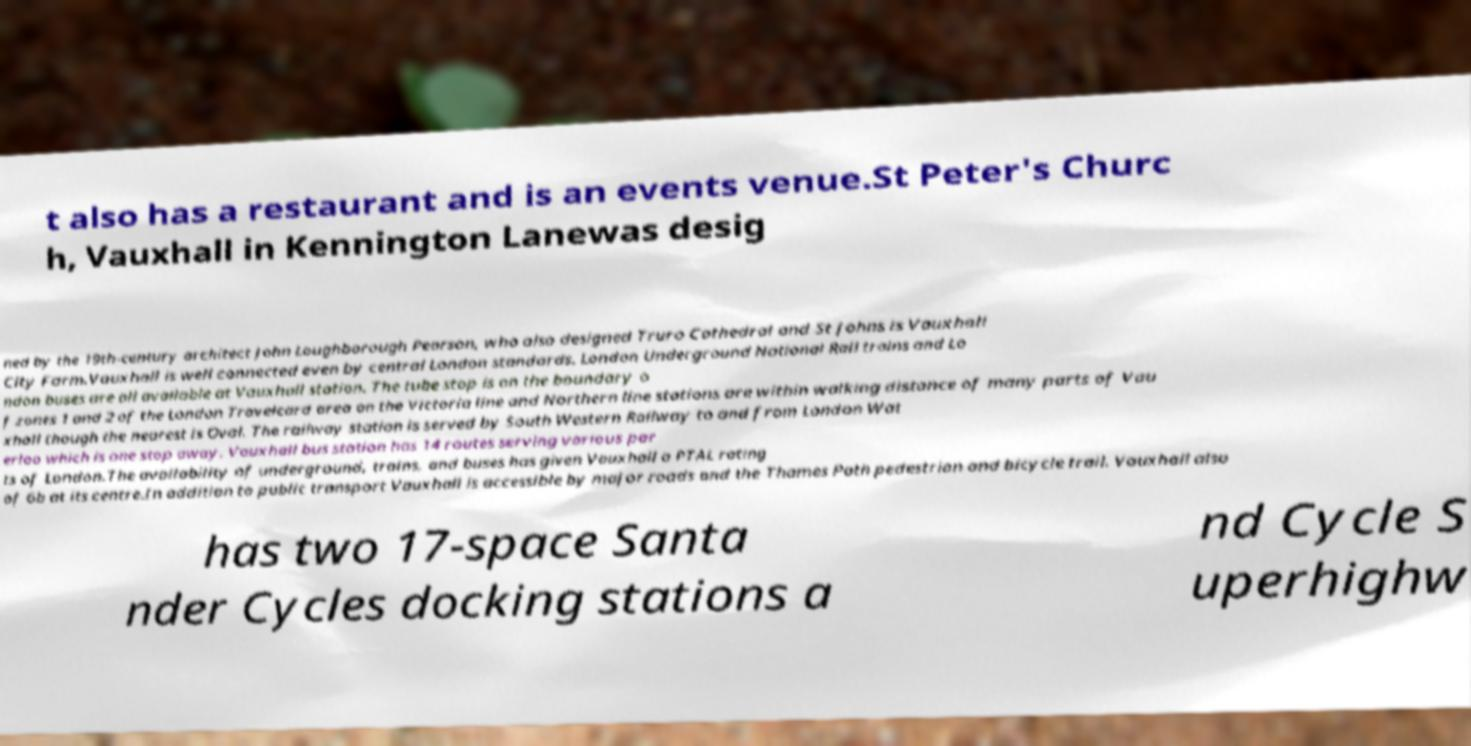Can you accurately transcribe the text from the provided image for me? t also has a restaurant and is an events venue.St Peter's Churc h, Vauxhall in Kennington Lanewas desig ned by the 19th-century architect John Loughborough Pearson, who also designed Truro Cathedral and St Johns is Vauxhall City Farm.Vauxhall is well connected even by central London standards. London Underground National Rail trains and Lo ndon buses are all available at Vauxhall station. The tube stop is on the boundary o f zones 1 and 2 of the London Travelcard area on the Victoria line and Northern line stations are within walking distance of many parts of Vau xhall though the nearest is Oval. The railway station is served by South Western Railway to and from London Wat erloo which is one stop away. Vauxhall bus station has 14 routes serving various par ts of London.The availability of underground, trains, and buses has given Vauxhall a PTAL rating of 6b at its centre.In addition to public transport Vauxhall is accessible by major roads and the Thames Path pedestrian and bicycle trail. Vauxhall also has two 17-space Santa nder Cycles docking stations a nd Cycle S uperhighw 